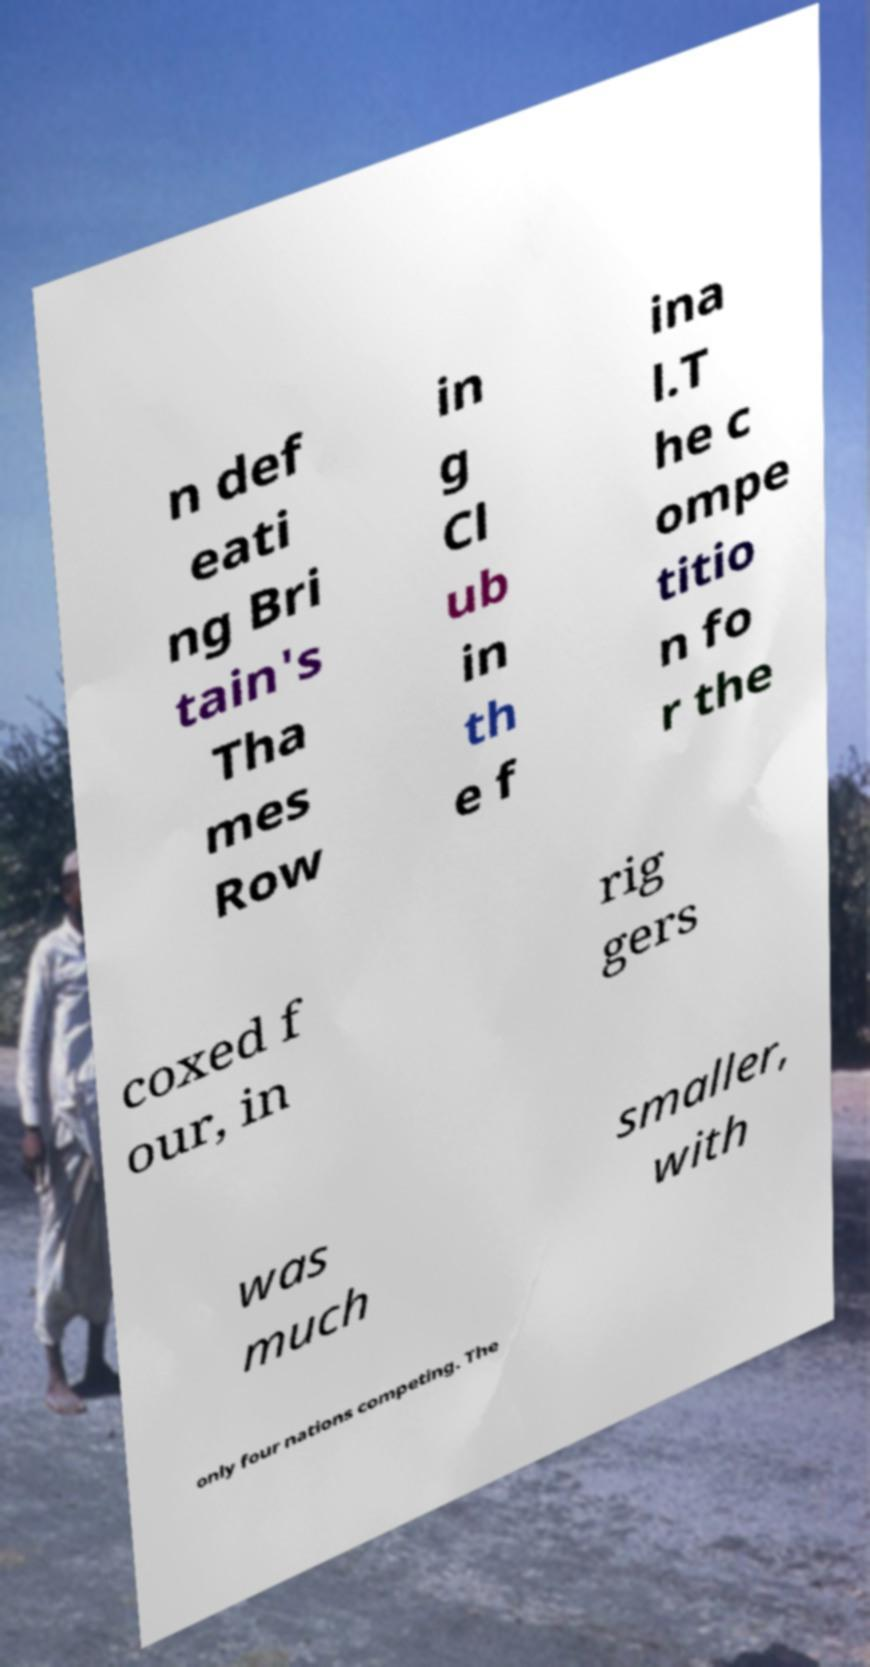Please read and relay the text visible in this image. What does it say? n def eati ng Bri tain's Tha mes Row in g Cl ub in th e f ina l.T he c ompe titio n fo r the coxed f our, in rig gers was much smaller, with only four nations competing. The 